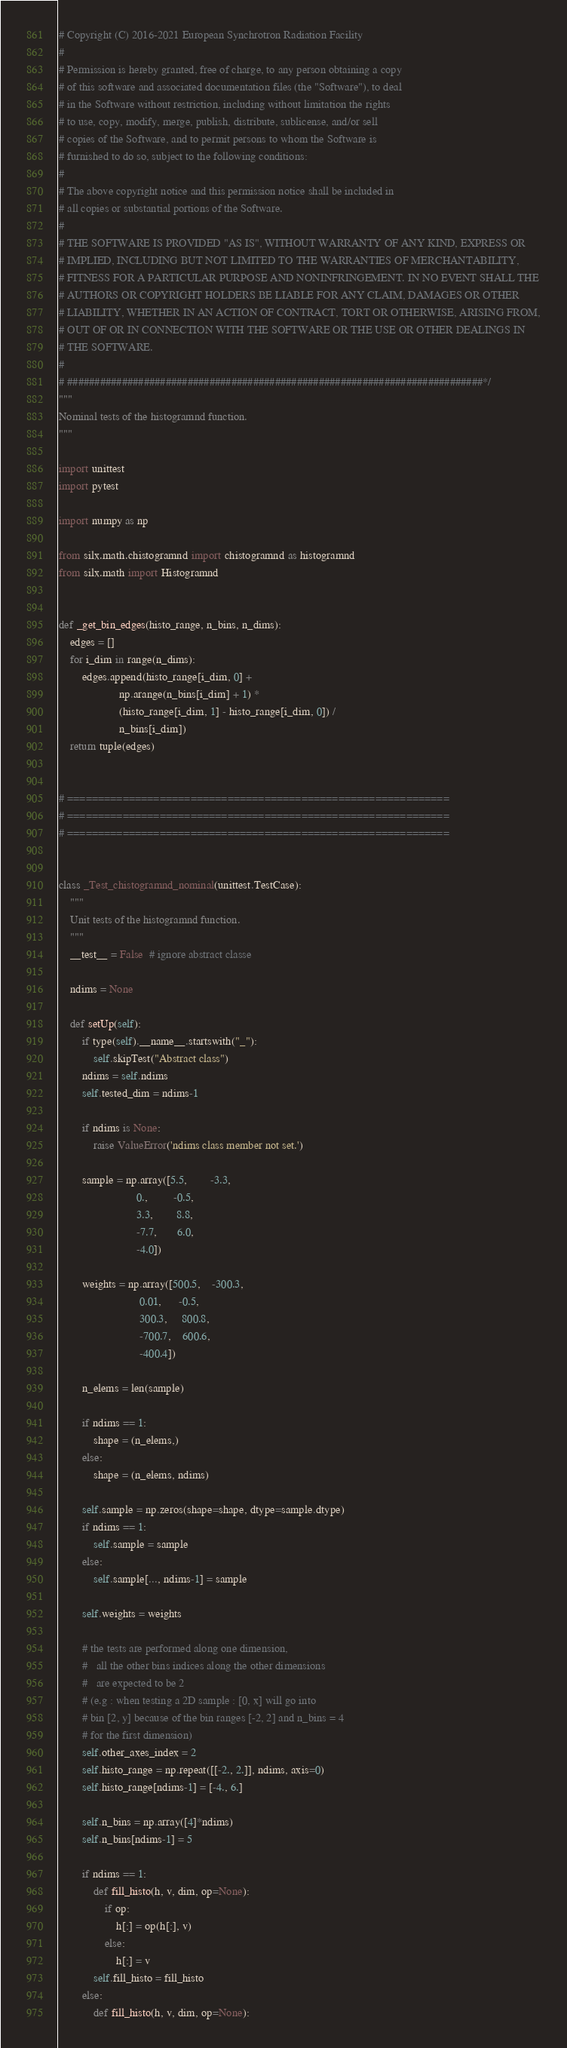<code> <loc_0><loc_0><loc_500><loc_500><_Python_># Copyright (C) 2016-2021 European Synchrotron Radiation Facility
#
# Permission is hereby granted, free of charge, to any person obtaining a copy
# of this software and associated documentation files (the "Software"), to deal
# in the Software without restriction, including without limitation the rights
# to use, copy, modify, merge, publish, distribute, sublicense, and/or sell
# copies of the Software, and to permit persons to whom the Software is
# furnished to do so, subject to the following conditions:
#
# The above copyright notice and this permission notice shall be included in
# all copies or substantial portions of the Software.
#
# THE SOFTWARE IS PROVIDED "AS IS", WITHOUT WARRANTY OF ANY KIND, EXPRESS OR
# IMPLIED, INCLUDING BUT NOT LIMITED TO THE WARRANTIES OF MERCHANTABILITY,
# FITNESS FOR A PARTICULAR PURPOSE AND NONINFRINGEMENT. IN NO EVENT SHALL THE
# AUTHORS OR COPYRIGHT HOLDERS BE LIABLE FOR ANY CLAIM, DAMAGES OR OTHER
# LIABILITY, WHETHER IN AN ACTION OF CONTRACT, TORT OR OTHERWISE, ARISING FROM,
# OUT OF OR IN CONNECTION WITH THE SOFTWARE OR THE USE OR OTHER DEALINGS IN
# THE SOFTWARE.
#
# ############################################################################*/
"""
Nominal tests of the histogramnd function.
"""

import unittest
import pytest

import numpy as np

from silx.math.chistogramnd import chistogramnd as histogramnd
from silx.math import Histogramnd


def _get_bin_edges(histo_range, n_bins, n_dims):
    edges = []
    for i_dim in range(n_dims):
        edges.append(histo_range[i_dim, 0] +
                     np.arange(n_bins[i_dim] + 1) *
                     (histo_range[i_dim, 1] - histo_range[i_dim, 0]) /
                     n_bins[i_dim])
    return tuple(edges)


# ==============================================================
# ==============================================================
# ==============================================================


class _Test_chistogramnd_nominal(unittest.TestCase):
    """
    Unit tests of the histogramnd function.
    """
    __test__ = False  # ignore abstract classe

    ndims = None

    def setUp(self):
        if type(self).__name__.startswith("_"):
            self.skipTest("Abstract class")
        ndims = self.ndims
        self.tested_dim = ndims-1

        if ndims is None:
            raise ValueError('ndims class member not set.')

        sample = np.array([5.5,        -3.3,
                           0.,         -0.5,
                           3.3,        8.8,
                           -7.7,       6.0,
                           -4.0])

        weights = np.array([500.5,    -300.3,
                            0.01,      -0.5,
                            300.3,     800.8,
                            -700.7,    600.6,
                            -400.4])

        n_elems = len(sample)

        if ndims == 1:
            shape = (n_elems,)
        else:
            shape = (n_elems, ndims)

        self.sample = np.zeros(shape=shape, dtype=sample.dtype)
        if ndims == 1:
            self.sample = sample
        else:
            self.sample[..., ndims-1] = sample

        self.weights = weights

        # the tests are performed along one dimension,
        #   all the other bins indices along the other dimensions
        #   are expected to be 2
        # (e.g : when testing a 2D sample : [0, x] will go into
        # bin [2, y] because of the bin ranges [-2, 2] and n_bins = 4
        # for the first dimension)
        self.other_axes_index = 2
        self.histo_range = np.repeat([[-2., 2.]], ndims, axis=0)
        self.histo_range[ndims-1] = [-4., 6.]

        self.n_bins = np.array([4]*ndims)
        self.n_bins[ndims-1] = 5

        if ndims == 1:
            def fill_histo(h, v, dim, op=None):
                if op:
                    h[:] = op(h[:], v)
                else:
                    h[:] = v
            self.fill_histo = fill_histo
        else:
            def fill_histo(h, v, dim, op=None):</code> 